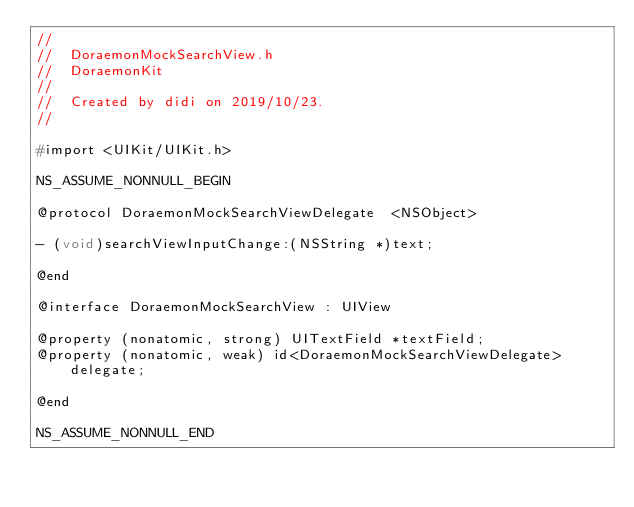Convert code to text. <code><loc_0><loc_0><loc_500><loc_500><_C_>//
//  DoraemonMockSearchView.h
//  DoraemonKit
//
//  Created by didi on 2019/10/23.
//

#import <UIKit/UIKit.h>

NS_ASSUME_NONNULL_BEGIN

@protocol DoraemonMockSearchViewDelegate  <NSObject>

- (void)searchViewInputChange:(NSString *)text;

@end

@interface DoraemonMockSearchView : UIView

@property (nonatomic, strong) UITextField *textField;
@property (nonatomic, weak) id<DoraemonMockSearchViewDelegate> delegate;

@end

NS_ASSUME_NONNULL_END
</code> 